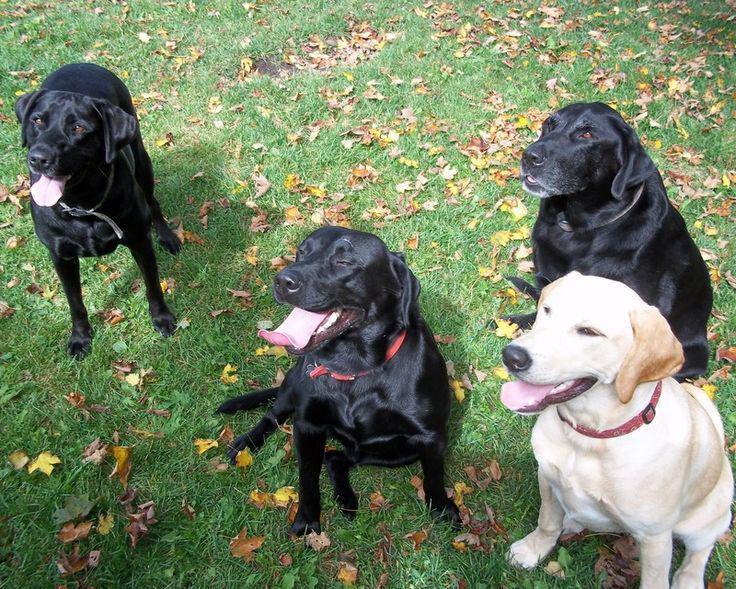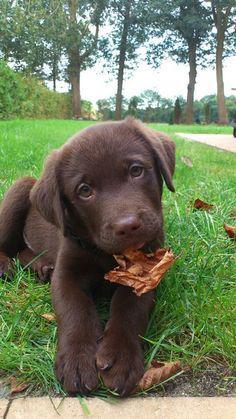The first image is the image on the left, the second image is the image on the right. For the images shown, is this caption "The dog on the left is wearing a back pack" true? Answer yes or no. No. The first image is the image on the left, the second image is the image on the right. For the images shown, is this caption "There is at least one dog wearing a red pack." true? Answer yes or no. No. 